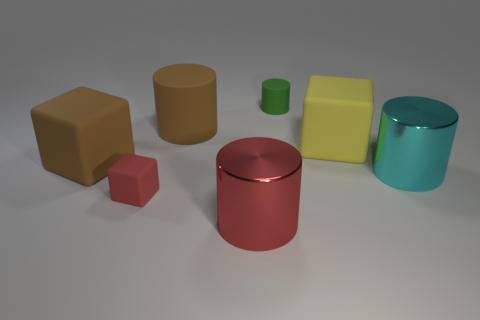Subtract all large brown matte cubes. How many cubes are left? 2 Add 2 green matte cylinders. How many objects exist? 9 Subtract 2 cylinders. How many cylinders are left? 2 Subtract all red cubes. How many cubes are left? 2 Subtract all cubes. How many objects are left? 4 Subtract all red cylinders. Subtract all blue cubes. How many cylinders are left? 3 Subtract all big cyan cylinders. Subtract all yellow matte things. How many objects are left? 5 Add 3 big yellow cubes. How many big yellow cubes are left? 4 Add 7 tiny blue things. How many tiny blue things exist? 7 Subtract 0 blue balls. How many objects are left? 7 